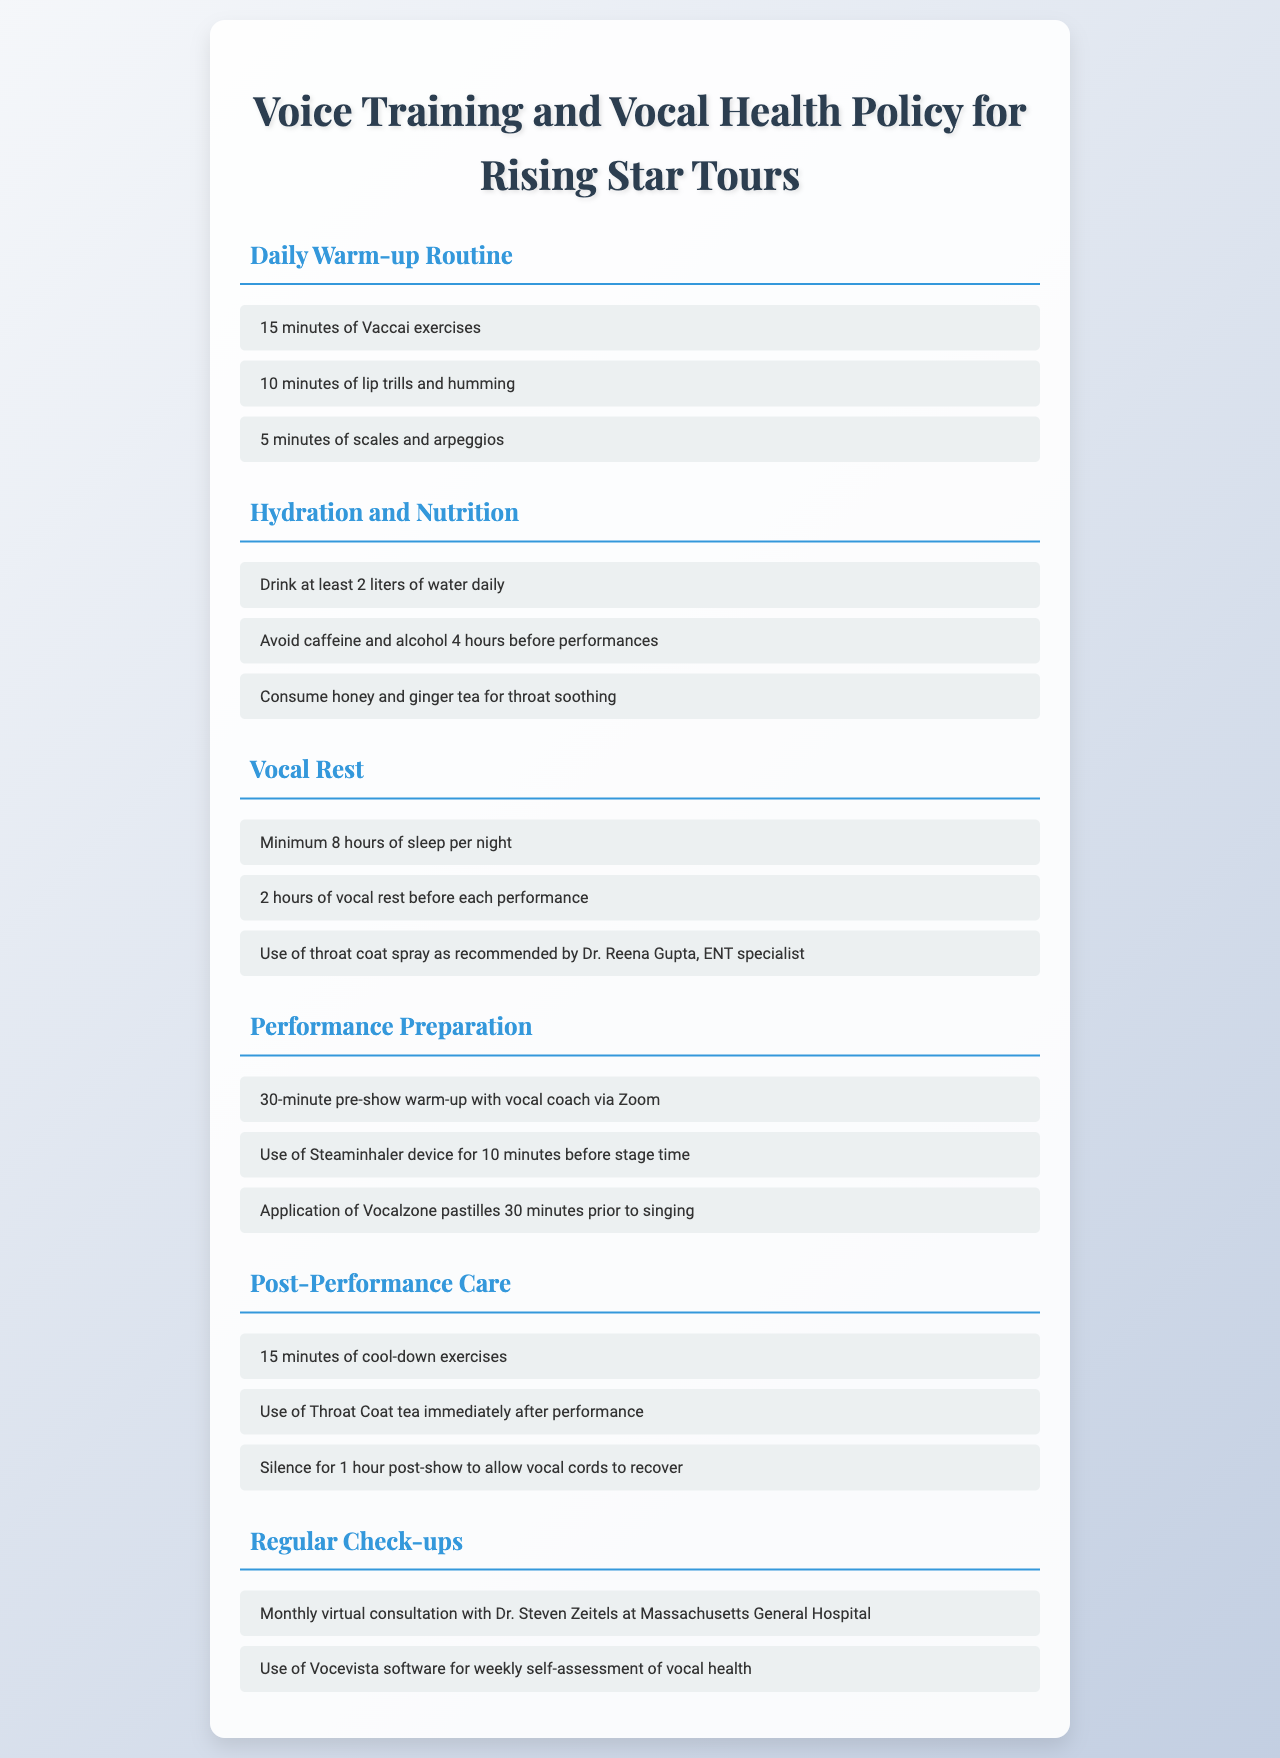What is the daily duration of Vaccai exercises? The document specifies that the daily warm-up routine includes 15 minutes of Vaccai exercises.
Answer: 15 minutes How much water should be consumed daily? The hydration and nutrition section states to drink at least 2 liters of water daily.
Answer: 2 liters What is the recommended amount of sleep per night? The vocal rest section states a minimum of 8 hours of sleep per night is necessary.
Answer: 8 hours What is the duration of the pre-show warm-up with the vocal coach? In the performance preparation section, it mentions a 30-minute pre-show warm-up.
Answer: 30 minutes Who provides the monthly virtual consultation? The regular check-ups section indicates monthly virtual consultations with Dr. Steven Zeitels.
Answer: Dr. Steven Zeitels What should be avoided 4 hours before performances? The hydration and nutrition section specifies to avoid caffeine and alcohol.
Answer: Caffeine and alcohol How long should you remain silent post-show? The post-performance care section advises silence for 1 hour post-show.
Answer: 1 hour What is recommended to use for throat soothing? The hydration and nutrition section suggests consuming honey and ginger tea for throat soothing.
Answer: Honey and ginger tea What device is suggested for use before stage time? The performance preparation section mentions using the Steaminhaler device for 10 minutes before stage time.
Answer: Steaminhaler 